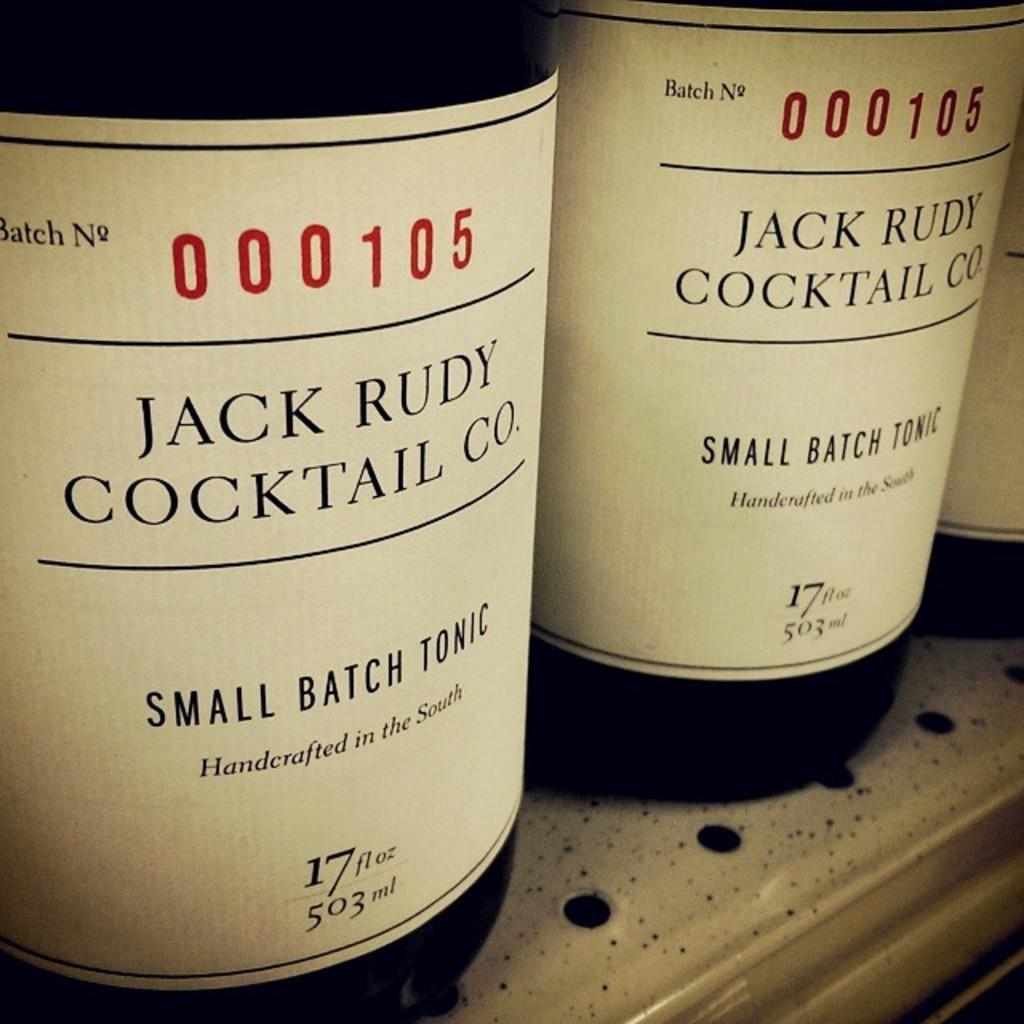<image>
Offer a succinct explanation of the picture presented. Bottles of Jack Rudy Cocktail co. small batch tonic are on the shelf. 